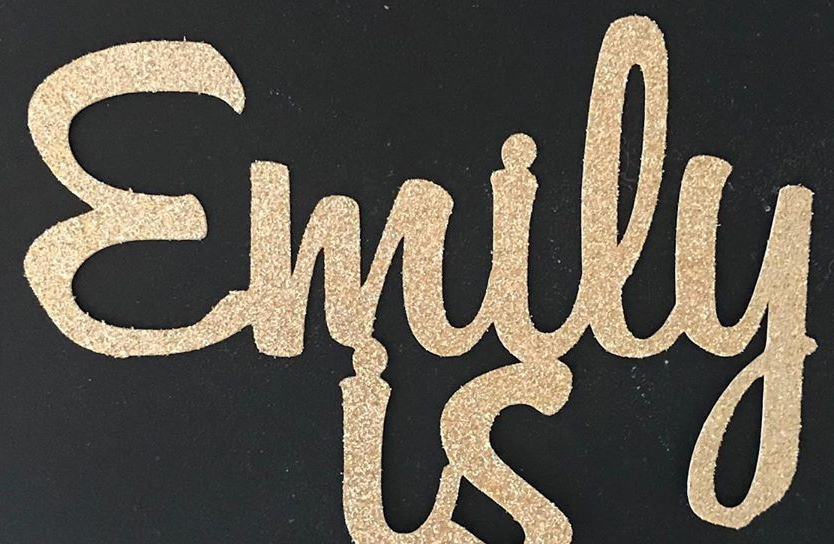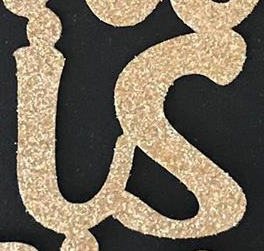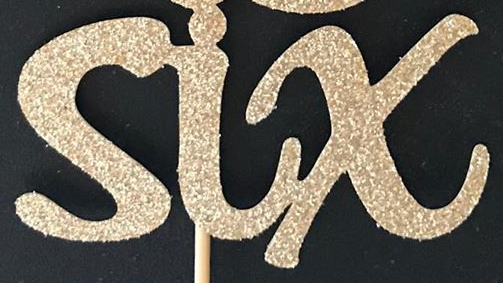What text is displayed in these images sequentially, separated by a semicolon? Emily; is; six 